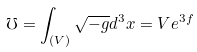<formula> <loc_0><loc_0><loc_500><loc_500>\mho = \int _ { ( V ) } \sqrt { - g } d ^ { 3 } x = V e ^ { 3 f }</formula> 